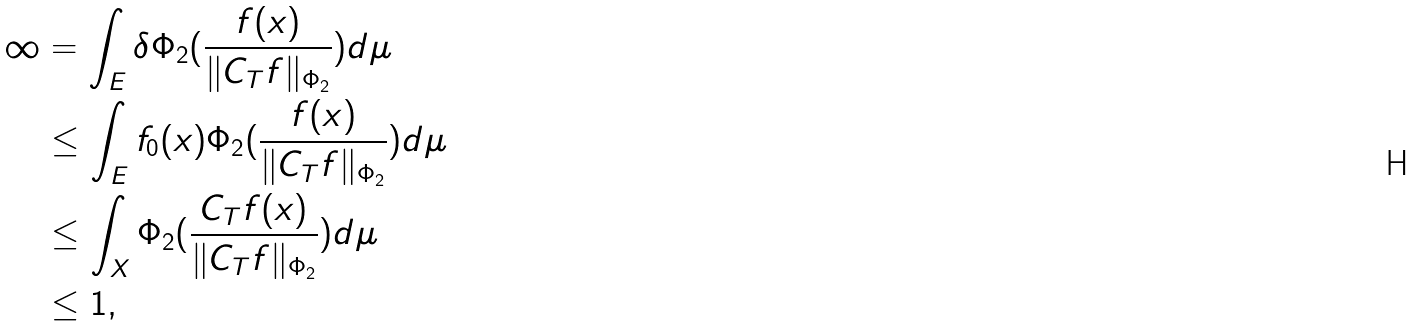<formula> <loc_0><loc_0><loc_500><loc_500>\infty & = \int _ { E } \delta \Phi _ { 2 } ( \frac { f ( x ) } { \| C _ { T } f \| _ { \Phi _ { 2 } } } ) d \mu \\ & \leq \int _ { E } f _ { 0 } ( x ) \Phi _ { 2 } ( \frac { f ( x ) } { \| C _ { T } f \| _ { \Phi _ { 2 } } } ) d \mu \\ & \leq \int _ { X } \Phi _ { 2 } ( \frac { C _ { T } f ( x ) } { \| C _ { T } f \| _ { \Phi _ { 2 } } } ) d \mu \\ & \leq 1 ,</formula> 